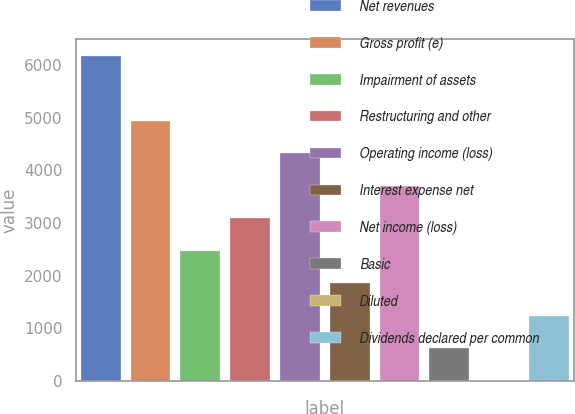Convert chart to OTSL. <chart><loc_0><loc_0><loc_500><loc_500><bar_chart><fcel>Net revenues<fcel>Gross profit (e)<fcel>Impairment of assets<fcel>Restructuring and other<fcel>Operating income (loss)<fcel>Interest expense net<fcel>Net income (loss)<fcel>Basic<fcel>Diluted<fcel>Dividends declared per common<nl><fcel>6182.3<fcel>4946.21<fcel>2474.09<fcel>3092.12<fcel>4328.18<fcel>1856.06<fcel>3710.15<fcel>620<fcel>1.97<fcel>1238.03<nl></chart> 